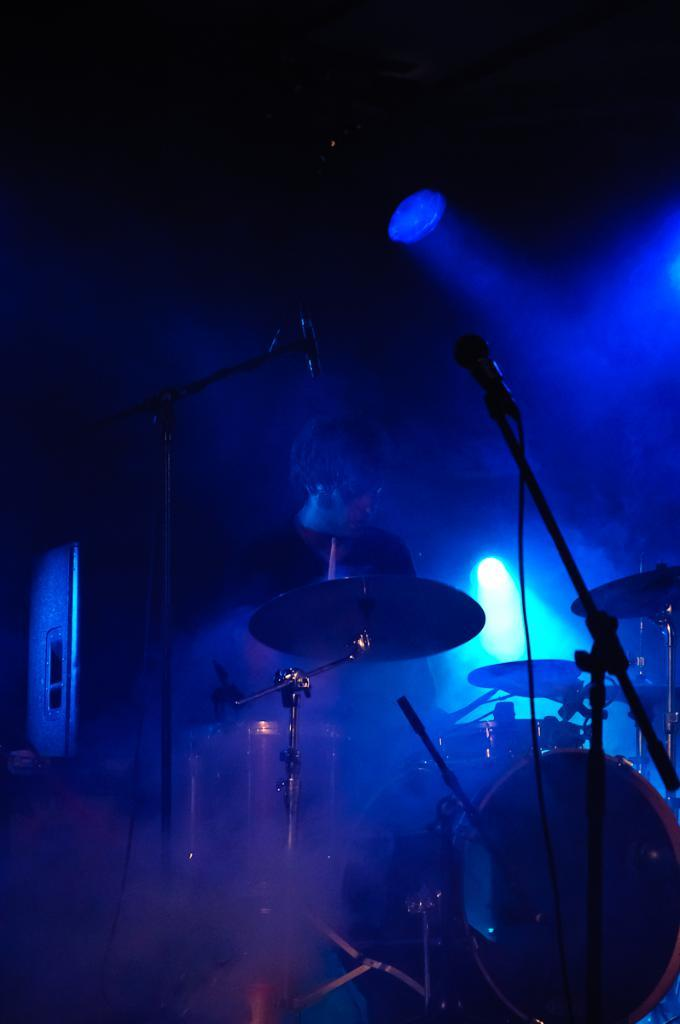What is the main subject of the image? There is a person standing in the image. What else can be seen in the image besides the person? There are musical instruments and a microphone (mic) present in the image. What might the person be using the mic for? The person might be using the mic for singing or speaking, as there are musical instruments in the image as well. What is the stand in the image used for? The stand in the image might be used for holding sheet music or lyrics for the person to read. How would you describe the lighting in the image? The background of the image is dark, but blue lights are visible. What type of haircut is the person getting in the image? There is no indication of a haircut in the image; the person is standing with musical instruments and a mic. What is the rate of the loaf in the image? There is no loaf present in the image, so it's not possible to determine a rate. 